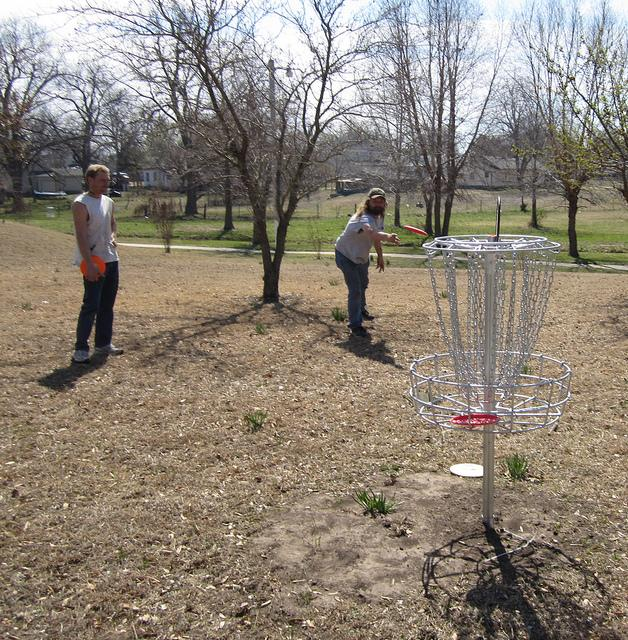What sport are the two men playing? frisbee 